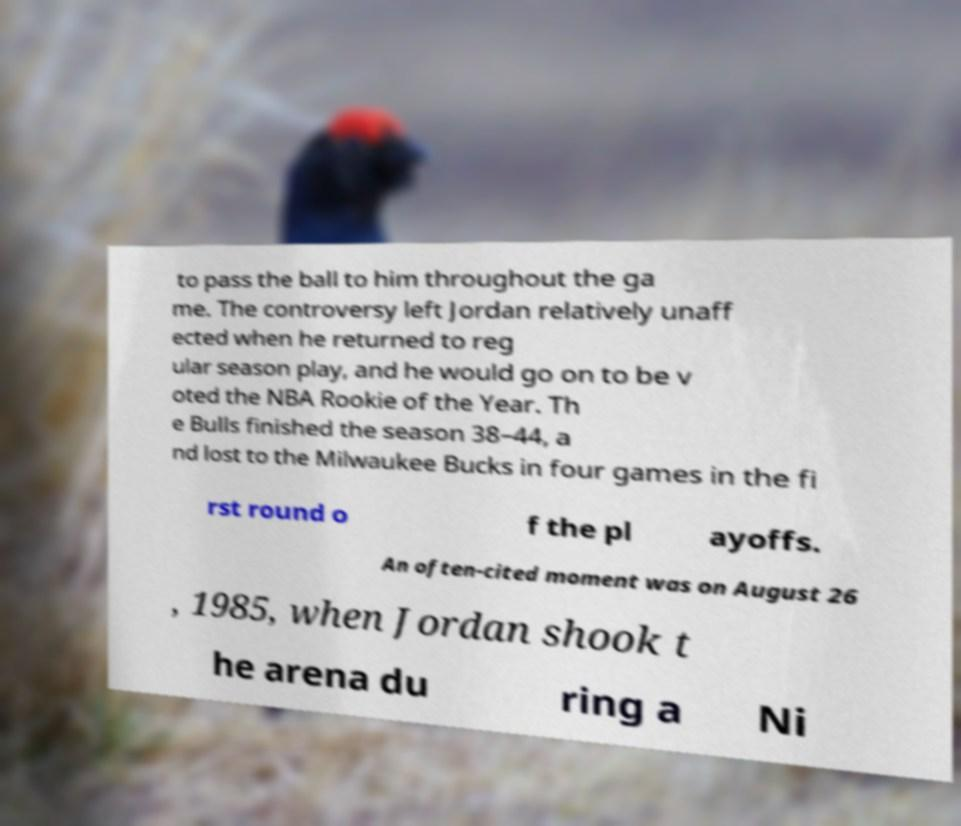For documentation purposes, I need the text within this image transcribed. Could you provide that? to pass the ball to him throughout the ga me. The controversy left Jordan relatively unaff ected when he returned to reg ular season play, and he would go on to be v oted the NBA Rookie of the Year. Th e Bulls finished the season 38–44, a nd lost to the Milwaukee Bucks in four games in the fi rst round o f the pl ayoffs. An often-cited moment was on August 26 , 1985, when Jordan shook t he arena du ring a Ni 